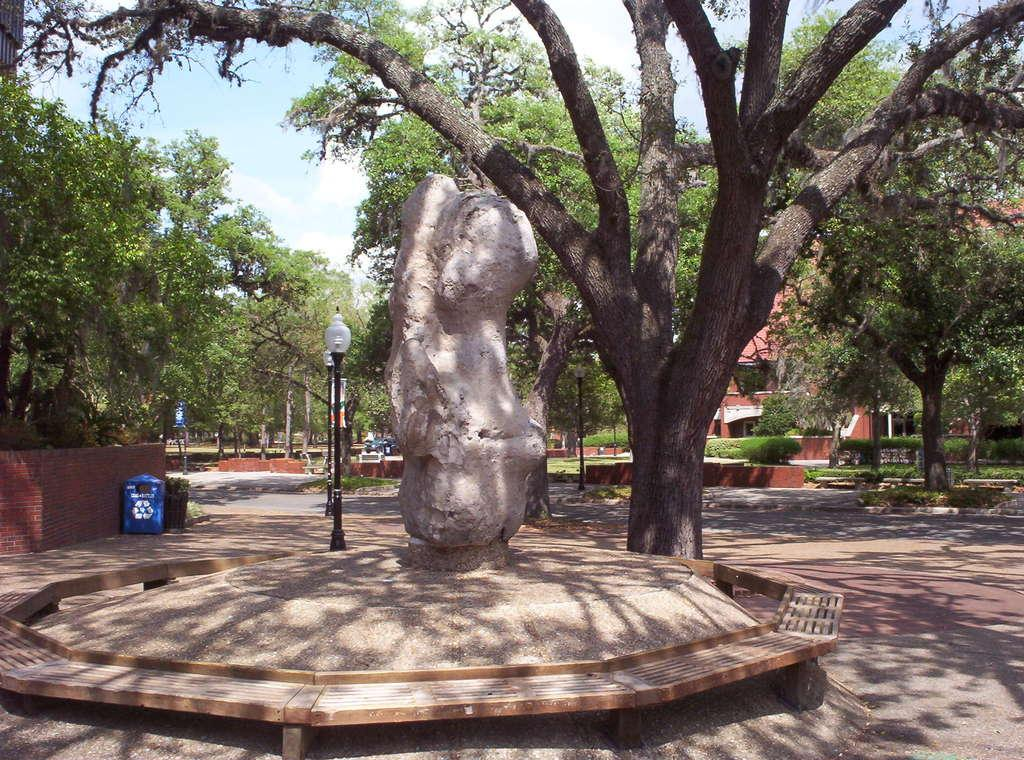What is the main subject in the middle of the image? There is a sculpture in the middle of the image. What can be seen behind the sculpture? There are trees behind the sculpture. What other objects are visible in the image? There are poles visible in the image. What is visible in the background of the image? There is a building in the background of the image. What type of corn is being used as bait for the argument in the image? There is no corn, bait, or argument present in the image. 